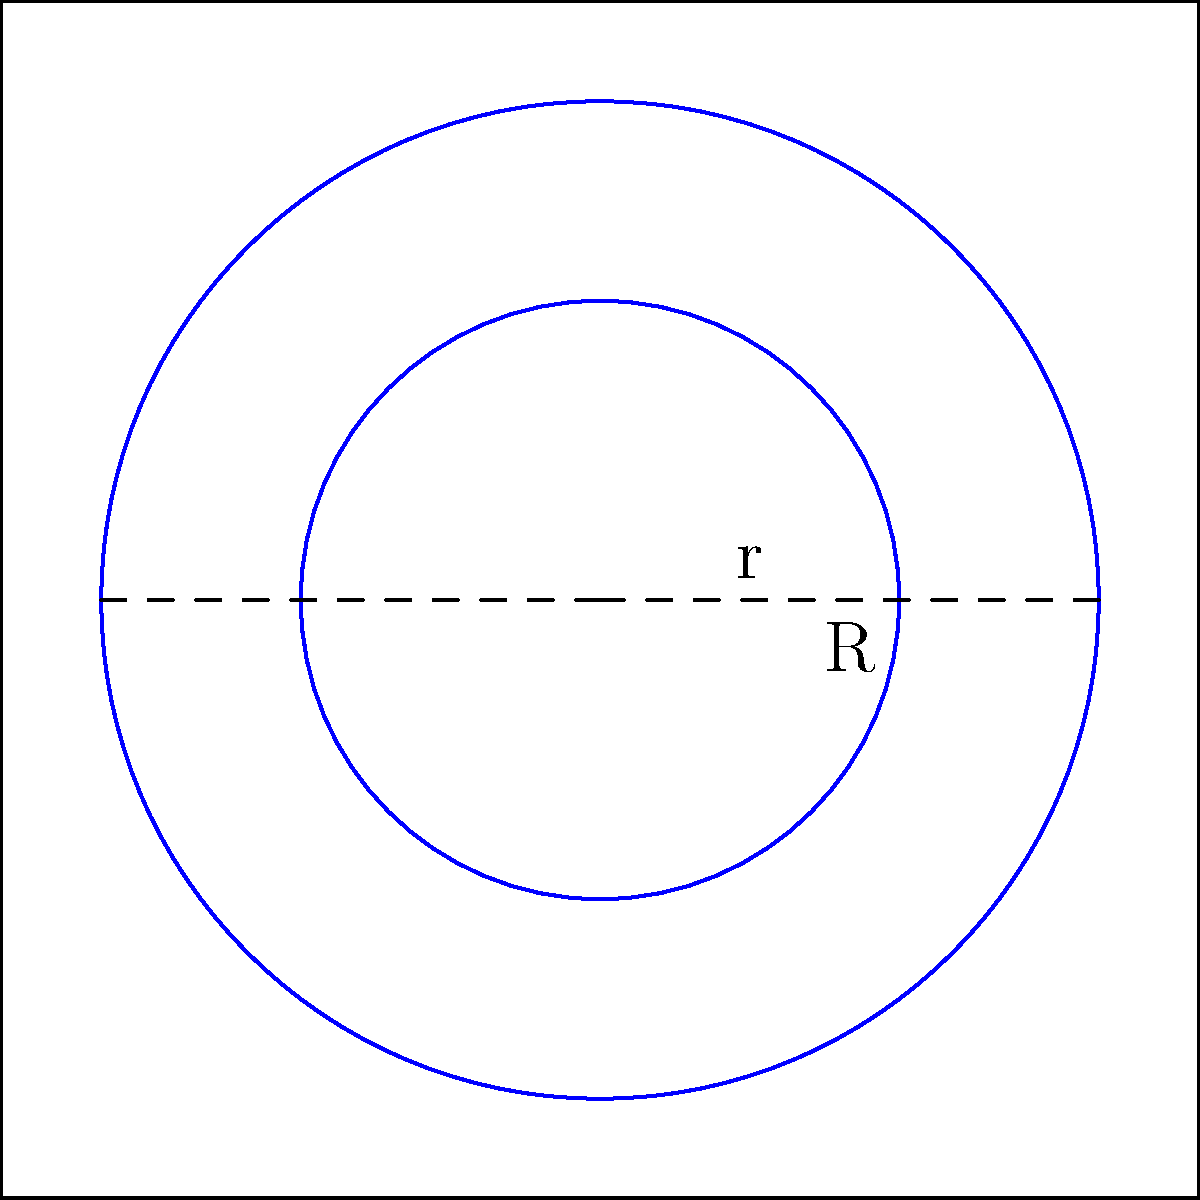As a marine surveyor, you need to calculate the area of a life ring for a vessel inspection. The life ring has an outer radius (R) of 50 cm and an inner radius (r) of 30 cm. What is the area of the life ring in square centimeters? (Use $\pi = 3.14$ for your calculations) To calculate the area of a life ring (annulus), we need to:

1. Calculate the area of the larger circle (outer circle):
   $A_1 = \pi R^2 = 3.14 \times 50^2 = 3.14 \times 2500 = 7850$ cm²

2. Calculate the area of the smaller circle (inner circle):
   $A_2 = \pi r^2 = 3.14 \times 30^2 = 3.14 \times 900 = 2826$ cm²

3. Subtract the area of the smaller circle from the larger circle:
   $A_{life ring} = A_1 - A_2 = 7850 - 2826 = 5024$ cm²

Therefore, the area of the life ring is 5024 square centimeters.
Answer: 5024 cm² 